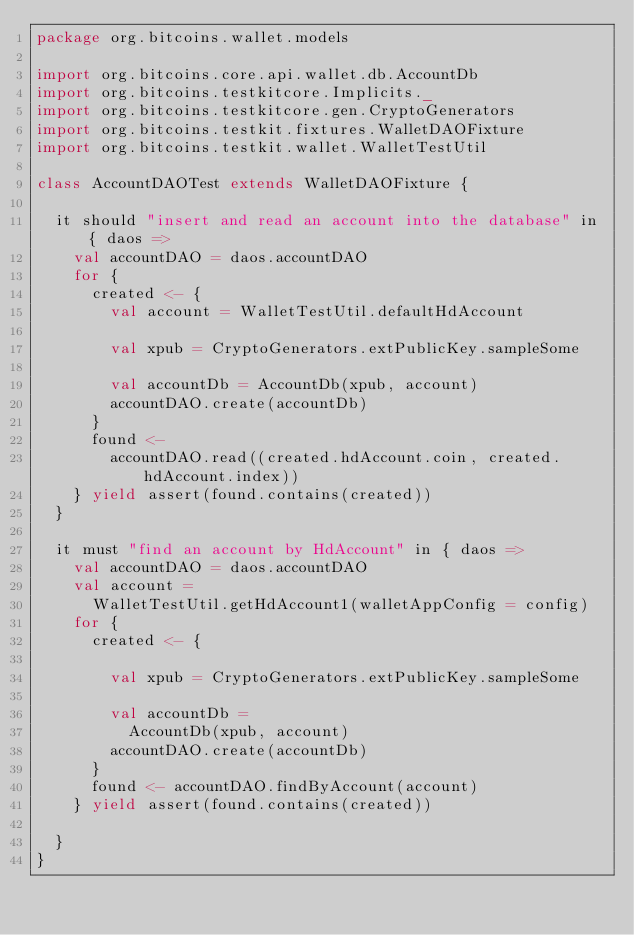Convert code to text. <code><loc_0><loc_0><loc_500><loc_500><_Scala_>package org.bitcoins.wallet.models

import org.bitcoins.core.api.wallet.db.AccountDb
import org.bitcoins.testkitcore.Implicits._
import org.bitcoins.testkitcore.gen.CryptoGenerators
import org.bitcoins.testkit.fixtures.WalletDAOFixture
import org.bitcoins.testkit.wallet.WalletTestUtil

class AccountDAOTest extends WalletDAOFixture {

  it should "insert and read an account into the database" in { daos =>
    val accountDAO = daos.accountDAO
    for {
      created <- {
        val account = WalletTestUtil.defaultHdAccount

        val xpub = CryptoGenerators.extPublicKey.sampleSome

        val accountDb = AccountDb(xpub, account)
        accountDAO.create(accountDb)
      }
      found <-
        accountDAO.read((created.hdAccount.coin, created.hdAccount.index))
    } yield assert(found.contains(created))
  }

  it must "find an account by HdAccount" in { daos =>
    val accountDAO = daos.accountDAO
    val account =
      WalletTestUtil.getHdAccount1(walletAppConfig = config)
    for {
      created <- {

        val xpub = CryptoGenerators.extPublicKey.sampleSome

        val accountDb =
          AccountDb(xpub, account)
        accountDAO.create(accountDb)
      }
      found <- accountDAO.findByAccount(account)
    } yield assert(found.contains(created))

  }
}
</code> 